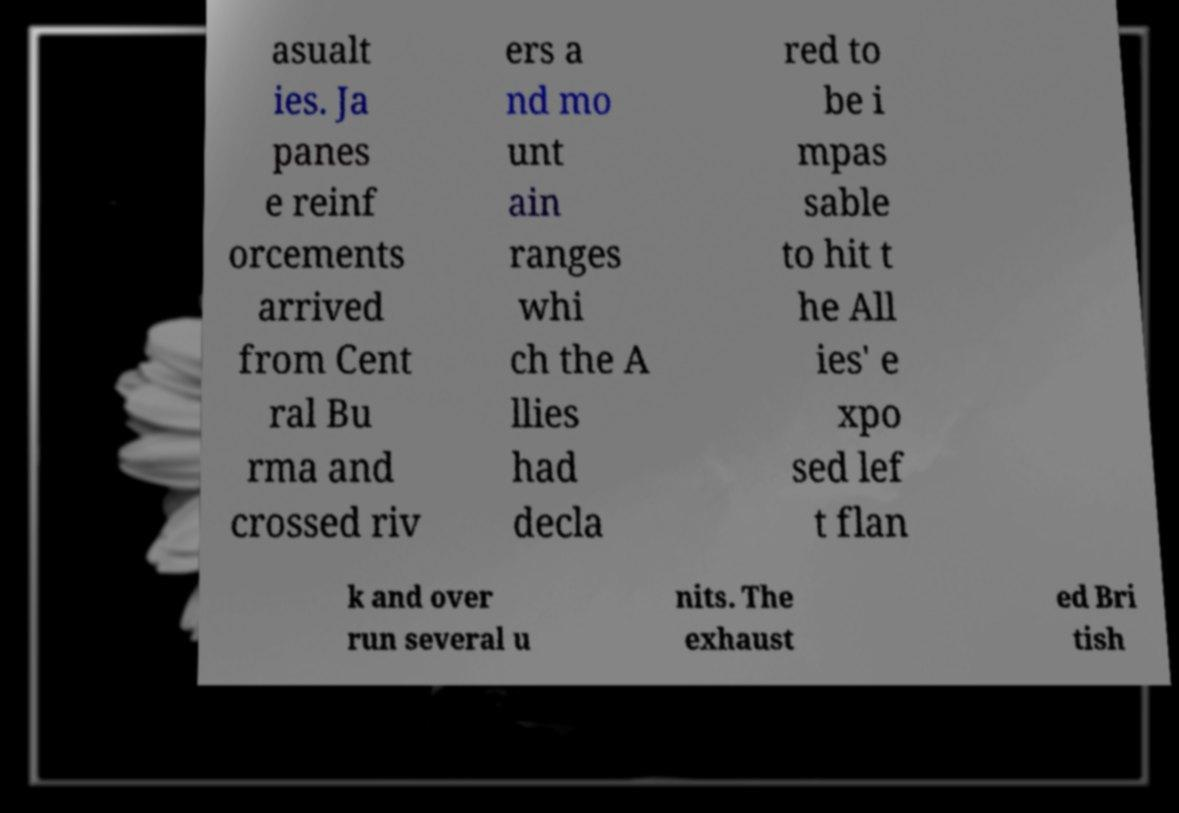There's text embedded in this image that I need extracted. Can you transcribe it verbatim? asualt ies. Ja panes e reinf orcements arrived from Cent ral Bu rma and crossed riv ers a nd mo unt ain ranges whi ch the A llies had decla red to be i mpas sable to hit t he All ies' e xpo sed lef t flan k and over run several u nits. The exhaust ed Bri tish 